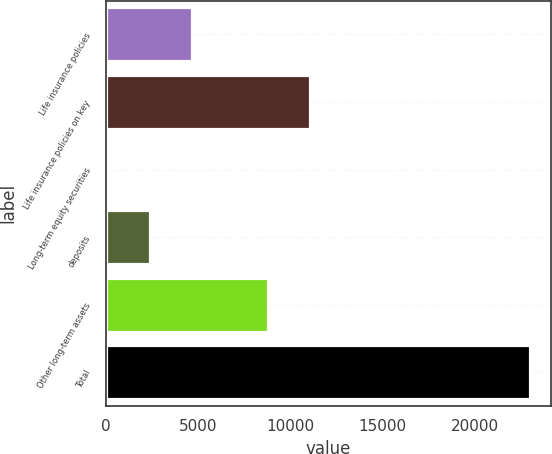Convert chart. <chart><loc_0><loc_0><loc_500><loc_500><bar_chart><fcel>Life insurance policies<fcel>Life insurance policies on key<fcel>Long-term equity securities<fcel>deposits<fcel>Other long-term assets<fcel>Total<nl><fcel>4678.2<fcel>11068.1<fcel>100<fcel>2389.1<fcel>8779<fcel>22991<nl></chart> 